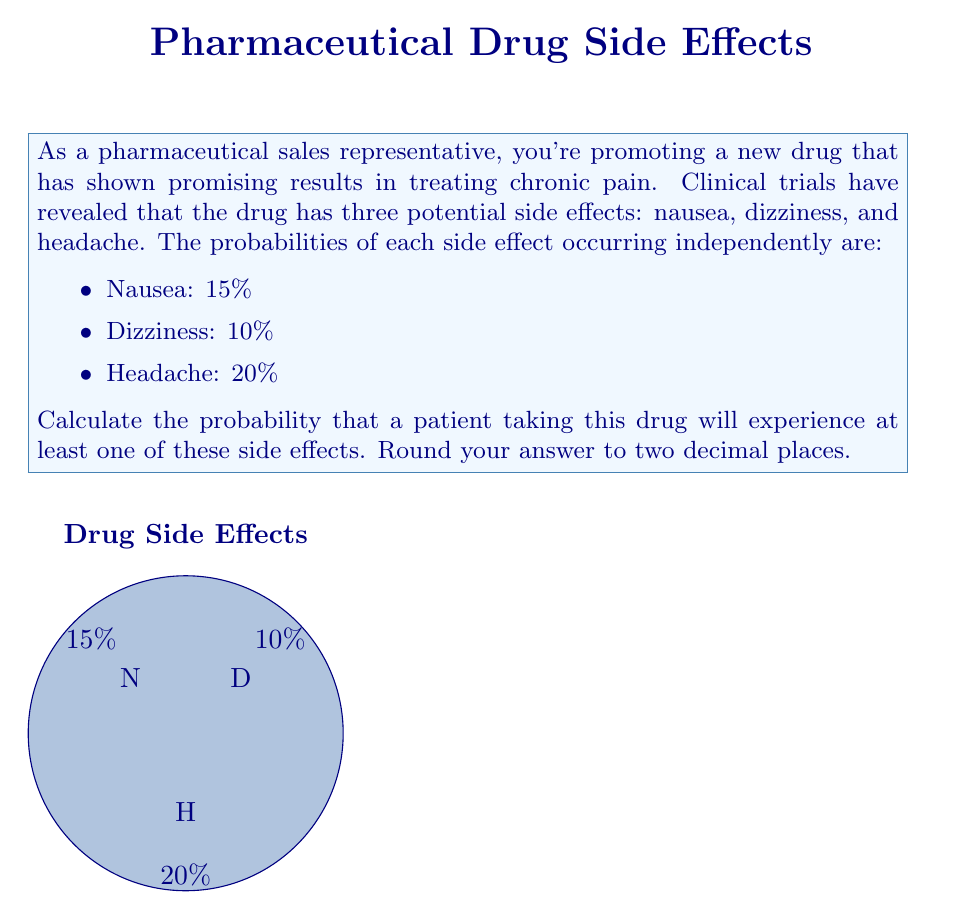Provide a solution to this math problem. To solve this problem, we'll use the concept of probability of the complement event. Instead of calculating the probability of at least one side effect occurring, we'll calculate the probability of no side effects occurring and then subtract it from 1.

Step 1: Calculate the probability of each side effect not occurring:
- P(No Nausea) = 1 - 0.15 = 0.85
- P(No Dizziness) = 1 - 0.10 = 0.90
- P(No Headache) = 1 - 0.20 = 0.80

Step 2: Calculate the probability of no side effects occurring (all events not occurring simultaneously):
$$P(\text{No Side Effects}) = 0.85 \times 0.90 \times 0.80 = 0.612$$

Step 3: Calculate the probability of at least one side effect occurring:
$$P(\text{At Least One Side Effect}) = 1 - P(\text{No Side Effects})$$
$$P(\text{At Least One Side Effect}) = 1 - 0.612 = 0.388$$

Step 4: Round the result to two decimal places:
$$0.388 \approx 0.39$$

Therefore, the probability that a patient taking this drug will experience at least one of these side effects is 0.39 or 39%.
Answer: 0.39 